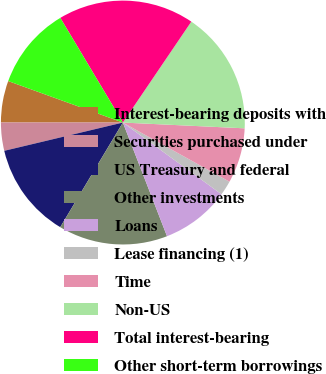<chart> <loc_0><loc_0><loc_500><loc_500><pie_chart><fcel>Interest-bearing deposits with<fcel>Securities purchased under<fcel>US Treasury and federal<fcel>Other investments<fcel>Loans<fcel>Lease financing (1)<fcel>Time<fcel>Non-US<fcel>Total interest-bearing<fcel>Other short-term borrowings<nl><fcel>5.52%<fcel>3.73%<fcel>12.69%<fcel>14.48%<fcel>9.1%<fcel>1.94%<fcel>7.31%<fcel>16.27%<fcel>18.06%<fcel>10.9%<nl></chart> 